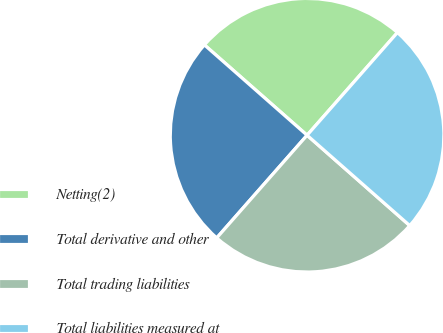Convert chart. <chart><loc_0><loc_0><loc_500><loc_500><pie_chart><fcel>Netting(2)<fcel>Total derivative and other<fcel>Total trading liabilities<fcel>Total liabilities measured at<nl><fcel>25.0%<fcel>25.0%<fcel>25.0%<fcel>25.0%<nl></chart> 